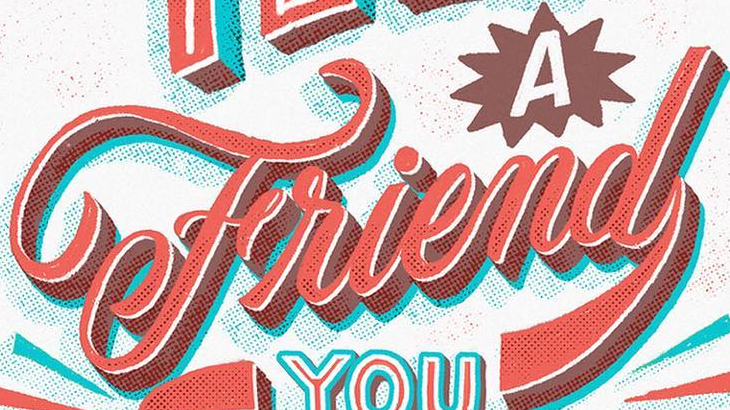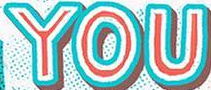Identify the words shown in these images in order, separated by a semicolon. Friend; YOU 